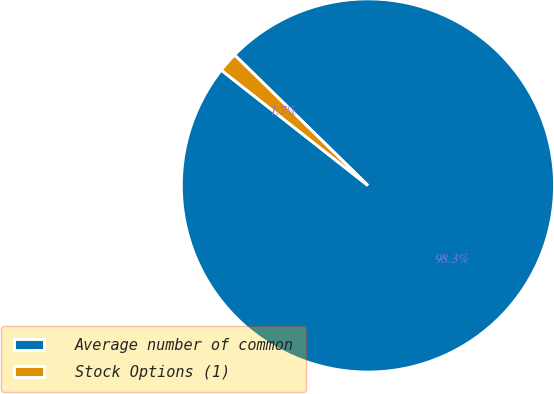Convert chart. <chart><loc_0><loc_0><loc_500><loc_500><pie_chart><fcel>Average number of common<fcel>Stock Options (1)<nl><fcel>98.28%<fcel>1.72%<nl></chart> 